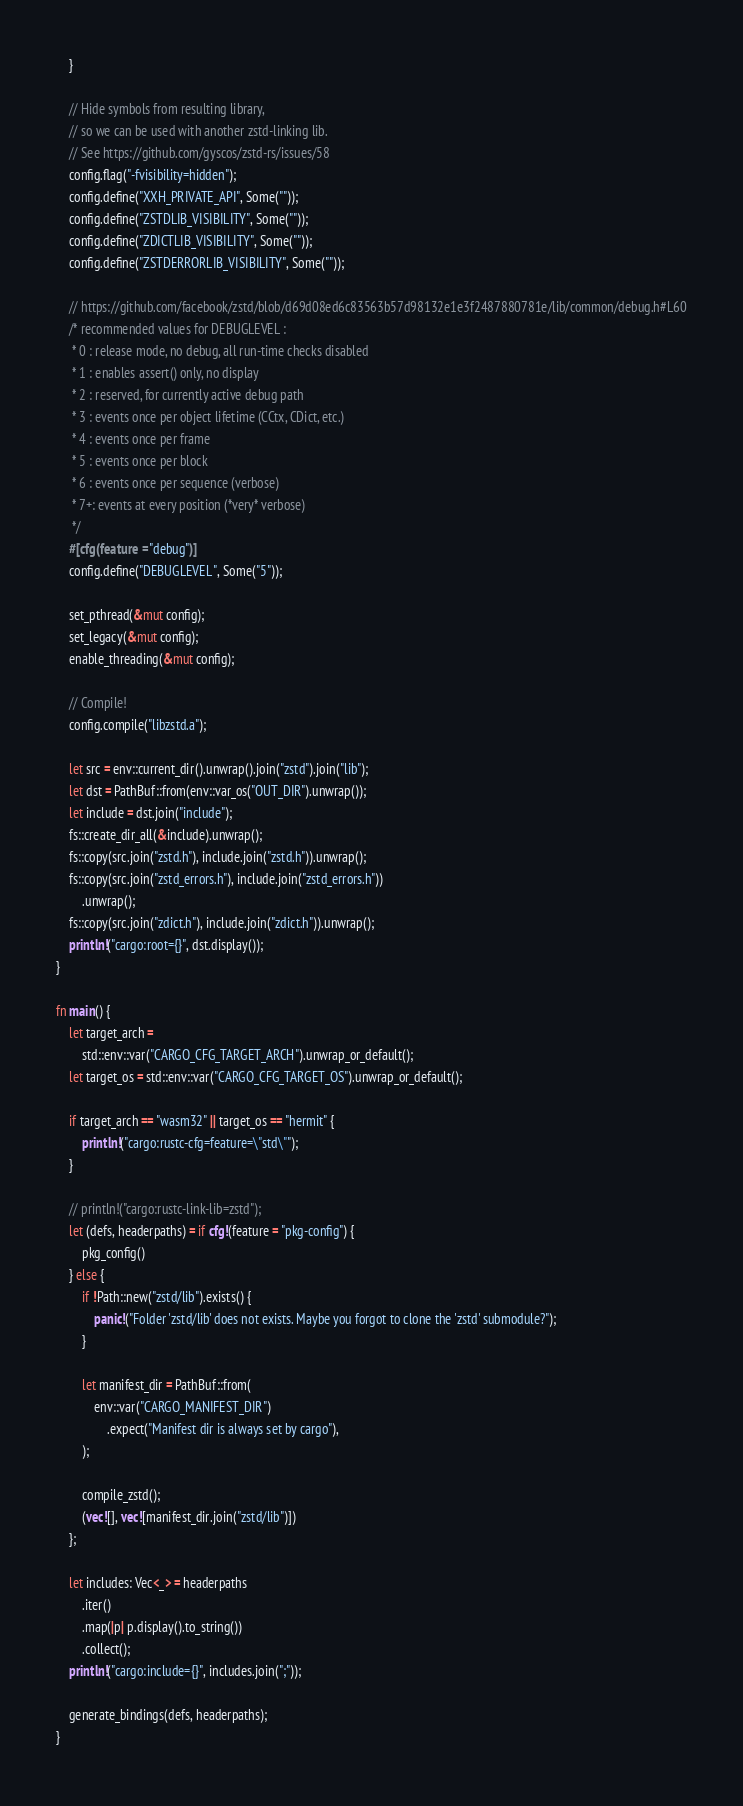Convert code to text. <code><loc_0><loc_0><loc_500><loc_500><_Rust_>    }

    // Hide symbols from resulting library,
    // so we can be used with another zstd-linking lib.
    // See https://github.com/gyscos/zstd-rs/issues/58
    config.flag("-fvisibility=hidden");
    config.define("XXH_PRIVATE_API", Some(""));
    config.define("ZSTDLIB_VISIBILITY", Some(""));
    config.define("ZDICTLIB_VISIBILITY", Some(""));
    config.define("ZSTDERRORLIB_VISIBILITY", Some(""));

    // https://github.com/facebook/zstd/blob/d69d08ed6c83563b57d98132e1e3f2487880781e/lib/common/debug.h#L60
    /* recommended values for DEBUGLEVEL :
     * 0 : release mode, no debug, all run-time checks disabled
     * 1 : enables assert() only, no display
     * 2 : reserved, for currently active debug path
     * 3 : events once per object lifetime (CCtx, CDict, etc.)
     * 4 : events once per frame
     * 5 : events once per block
     * 6 : events once per sequence (verbose)
     * 7+: events at every position (*very* verbose)
     */
    #[cfg(feature = "debug")]
    config.define("DEBUGLEVEL", Some("5"));

    set_pthread(&mut config);
    set_legacy(&mut config);
    enable_threading(&mut config);

    // Compile!
    config.compile("libzstd.a");

    let src = env::current_dir().unwrap().join("zstd").join("lib");
    let dst = PathBuf::from(env::var_os("OUT_DIR").unwrap());
    let include = dst.join("include");
    fs::create_dir_all(&include).unwrap();
    fs::copy(src.join("zstd.h"), include.join("zstd.h")).unwrap();
    fs::copy(src.join("zstd_errors.h"), include.join("zstd_errors.h"))
        .unwrap();
    fs::copy(src.join("zdict.h"), include.join("zdict.h")).unwrap();
    println!("cargo:root={}", dst.display());
}

fn main() {
    let target_arch =
        std::env::var("CARGO_CFG_TARGET_ARCH").unwrap_or_default();
    let target_os = std::env::var("CARGO_CFG_TARGET_OS").unwrap_or_default();

    if target_arch == "wasm32" || target_os == "hermit" {
        println!("cargo:rustc-cfg=feature=\"std\"");
    }

    // println!("cargo:rustc-link-lib=zstd");
    let (defs, headerpaths) = if cfg!(feature = "pkg-config") {
        pkg_config()
    } else {
        if !Path::new("zstd/lib").exists() {
            panic!("Folder 'zstd/lib' does not exists. Maybe you forgot to clone the 'zstd' submodule?");
        }

        let manifest_dir = PathBuf::from(
            env::var("CARGO_MANIFEST_DIR")
                .expect("Manifest dir is always set by cargo"),
        );

        compile_zstd();
        (vec![], vec![manifest_dir.join("zstd/lib")])
    };

    let includes: Vec<_> = headerpaths
        .iter()
        .map(|p| p.display().to_string())
        .collect();
    println!("cargo:include={}", includes.join(";"));

    generate_bindings(defs, headerpaths);
}
</code> 